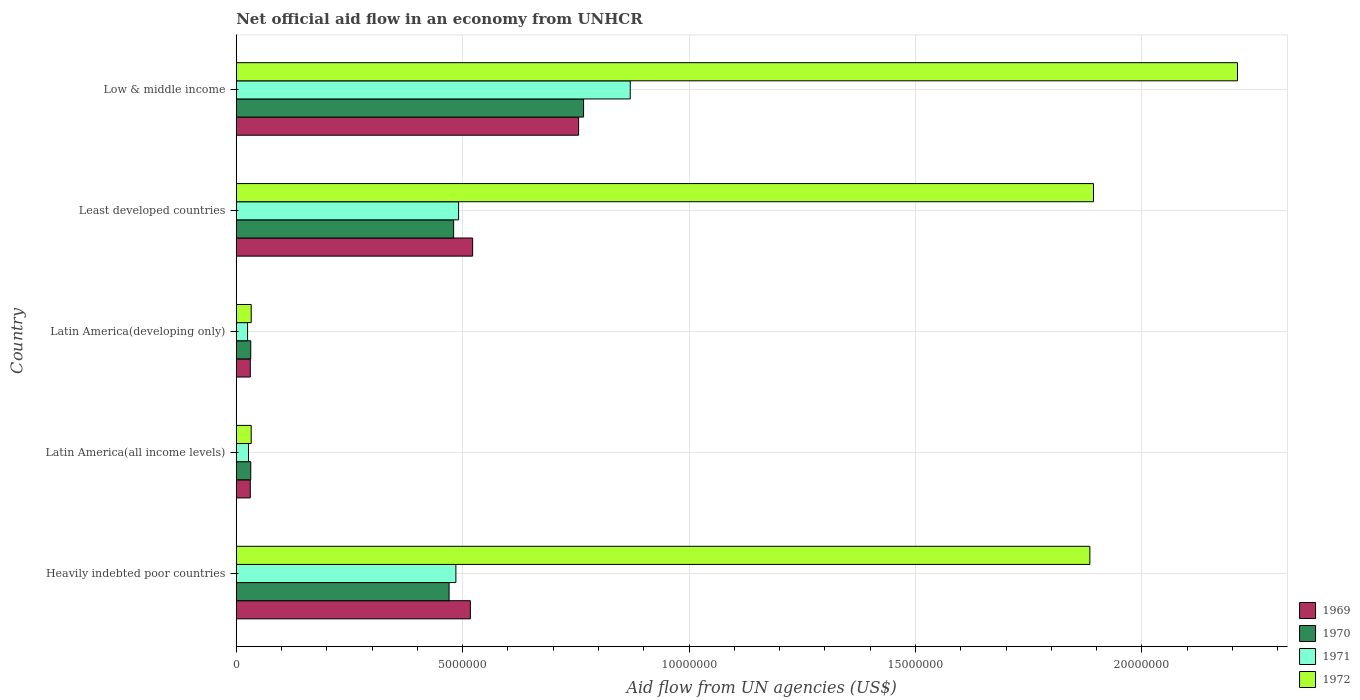Are the number of bars per tick equal to the number of legend labels?
Your answer should be compact. Yes. What is the label of the 2nd group of bars from the top?
Provide a succinct answer. Least developed countries. What is the net official aid flow in 1972 in Heavily indebted poor countries?
Give a very brief answer. 1.88e+07. Across all countries, what is the maximum net official aid flow in 1969?
Your response must be concise. 7.56e+06. Across all countries, what is the minimum net official aid flow in 1972?
Offer a terse response. 3.30e+05. In which country was the net official aid flow in 1971 minimum?
Offer a very short reply. Latin America(developing only). What is the total net official aid flow in 1969 in the graph?
Offer a terse response. 1.86e+07. What is the difference between the net official aid flow in 1971 in Heavily indebted poor countries and that in Latin America(developing only)?
Your answer should be compact. 4.60e+06. What is the average net official aid flow in 1969 per country?
Your response must be concise. 3.71e+06. What is the difference between the net official aid flow in 1971 and net official aid flow in 1970 in Latin America(developing only)?
Your answer should be very brief. -7.00e+04. In how many countries, is the net official aid flow in 1971 greater than 14000000 US$?
Give a very brief answer. 0. What is the ratio of the net official aid flow in 1969 in Latin America(developing only) to that in Least developed countries?
Keep it short and to the point. 0.06. Is the net official aid flow in 1971 in Latin America(all income levels) less than that in Least developed countries?
Make the answer very short. Yes. What is the difference between the highest and the second highest net official aid flow in 1971?
Make the answer very short. 3.79e+06. What is the difference between the highest and the lowest net official aid flow in 1969?
Offer a terse response. 7.25e+06. In how many countries, is the net official aid flow in 1969 greater than the average net official aid flow in 1969 taken over all countries?
Your response must be concise. 3. Is the sum of the net official aid flow in 1971 in Latin America(all income levels) and Latin America(developing only) greater than the maximum net official aid flow in 1969 across all countries?
Provide a short and direct response. No. Is it the case that in every country, the sum of the net official aid flow in 1971 and net official aid flow in 1969 is greater than the sum of net official aid flow in 1972 and net official aid flow in 1970?
Ensure brevity in your answer.  No. What does the 4th bar from the top in Least developed countries represents?
Offer a terse response. 1969. What does the 3rd bar from the bottom in Least developed countries represents?
Give a very brief answer. 1971. How many countries are there in the graph?
Provide a succinct answer. 5. What is the difference between two consecutive major ticks on the X-axis?
Your answer should be very brief. 5.00e+06. How many legend labels are there?
Your response must be concise. 4. What is the title of the graph?
Offer a very short reply. Net official aid flow in an economy from UNHCR. What is the label or title of the X-axis?
Your answer should be compact. Aid flow from UN agencies (US$). What is the Aid flow from UN agencies (US$) of 1969 in Heavily indebted poor countries?
Your answer should be compact. 5.17e+06. What is the Aid flow from UN agencies (US$) in 1970 in Heavily indebted poor countries?
Give a very brief answer. 4.70e+06. What is the Aid flow from UN agencies (US$) of 1971 in Heavily indebted poor countries?
Your response must be concise. 4.85e+06. What is the Aid flow from UN agencies (US$) in 1972 in Heavily indebted poor countries?
Keep it short and to the point. 1.88e+07. What is the Aid flow from UN agencies (US$) in 1970 in Latin America(all income levels)?
Make the answer very short. 3.20e+05. What is the Aid flow from UN agencies (US$) of 1971 in Latin America(all income levels)?
Your response must be concise. 2.70e+05. What is the Aid flow from UN agencies (US$) of 1972 in Latin America(all income levels)?
Your answer should be very brief. 3.30e+05. What is the Aid flow from UN agencies (US$) of 1970 in Latin America(developing only)?
Your answer should be compact. 3.20e+05. What is the Aid flow from UN agencies (US$) in 1969 in Least developed countries?
Offer a terse response. 5.22e+06. What is the Aid flow from UN agencies (US$) in 1970 in Least developed countries?
Offer a terse response. 4.80e+06. What is the Aid flow from UN agencies (US$) in 1971 in Least developed countries?
Your answer should be very brief. 4.91e+06. What is the Aid flow from UN agencies (US$) in 1972 in Least developed countries?
Your answer should be very brief. 1.89e+07. What is the Aid flow from UN agencies (US$) in 1969 in Low & middle income?
Your answer should be very brief. 7.56e+06. What is the Aid flow from UN agencies (US$) of 1970 in Low & middle income?
Offer a very short reply. 7.67e+06. What is the Aid flow from UN agencies (US$) in 1971 in Low & middle income?
Your answer should be very brief. 8.70e+06. What is the Aid flow from UN agencies (US$) of 1972 in Low & middle income?
Offer a terse response. 2.21e+07. Across all countries, what is the maximum Aid flow from UN agencies (US$) of 1969?
Offer a terse response. 7.56e+06. Across all countries, what is the maximum Aid flow from UN agencies (US$) of 1970?
Keep it short and to the point. 7.67e+06. Across all countries, what is the maximum Aid flow from UN agencies (US$) in 1971?
Your answer should be very brief. 8.70e+06. Across all countries, what is the maximum Aid flow from UN agencies (US$) in 1972?
Your answer should be compact. 2.21e+07. Across all countries, what is the minimum Aid flow from UN agencies (US$) of 1972?
Offer a very short reply. 3.30e+05. What is the total Aid flow from UN agencies (US$) in 1969 in the graph?
Provide a succinct answer. 1.86e+07. What is the total Aid flow from UN agencies (US$) of 1970 in the graph?
Your response must be concise. 1.78e+07. What is the total Aid flow from UN agencies (US$) in 1971 in the graph?
Give a very brief answer. 1.90e+07. What is the total Aid flow from UN agencies (US$) of 1972 in the graph?
Your answer should be compact. 6.06e+07. What is the difference between the Aid flow from UN agencies (US$) of 1969 in Heavily indebted poor countries and that in Latin America(all income levels)?
Provide a succinct answer. 4.86e+06. What is the difference between the Aid flow from UN agencies (US$) in 1970 in Heavily indebted poor countries and that in Latin America(all income levels)?
Provide a short and direct response. 4.38e+06. What is the difference between the Aid flow from UN agencies (US$) in 1971 in Heavily indebted poor countries and that in Latin America(all income levels)?
Provide a succinct answer. 4.58e+06. What is the difference between the Aid flow from UN agencies (US$) in 1972 in Heavily indebted poor countries and that in Latin America(all income levels)?
Your answer should be very brief. 1.85e+07. What is the difference between the Aid flow from UN agencies (US$) of 1969 in Heavily indebted poor countries and that in Latin America(developing only)?
Provide a short and direct response. 4.86e+06. What is the difference between the Aid flow from UN agencies (US$) of 1970 in Heavily indebted poor countries and that in Latin America(developing only)?
Keep it short and to the point. 4.38e+06. What is the difference between the Aid flow from UN agencies (US$) in 1971 in Heavily indebted poor countries and that in Latin America(developing only)?
Keep it short and to the point. 4.60e+06. What is the difference between the Aid flow from UN agencies (US$) of 1972 in Heavily indebted poor countries and that in Latin America(developing only)?
Offer a very short reply. 1.85e+07. What is the difference between the Aid flow from UN agencies (US$) of 1969 in Heavily indebted poor countries and that in Least developed countries?
Provide a succinct answer. -5.00e+04. What is the difference between the Aid flow from UN agencies (US$) of 1970 in Heavily indebted poor countries and that in Least developed countries?
Keep it short and to the point. -1.00e+05. What is the difference between the Aid flow from UN agencies (US$) in 1972 in Heavily indebted poor countries and that in Least developed countries?
Your answer should be very brief. -8.00e+04. What is the difference between the Aid flow from UN agencies (US$) of 1969 in Heavily indebted poor countries and that in Low & middle income?
Provide a short and direct response. -2.39e+06. What is the difference between the Aid flow from UN agencies (US$) in 1970 in Heavily indebted poor countries and that in Low & middle income?
Offer a terse response. -2.97e+06. What is the difference between the Aid flow from UN agencies (US$) of 1971 in Heavily indebted poor countries and that in Low & middle income?
Ensure brevity in your answer.  -3.85e+06. What is the difference between the Aid flow from UN agencies (US$) in 1972 in Heavily indebted poor countries and that in Low & middle income?
Offer a terse response. -3.26e+06. What is the difference between the Aid flow from UN agencies (US$) in 1969 in Latin America(all income levels) and that in Least developed countries?
Your answer should be very brief. -4.91e+06. What is the difference between the Aid flow from UN agencies (US$) in 1970 in Latin America(all income levels) and that in Least developed countries?
Your response must be concise. -4.48e+06. What is the difference between the Aid flow from UN agencies (US$) of 1971 in Latin America(all income levels) and that in Least developed countries?
Offer a terse response. -4.64e+06. What is the difference between the Aid flow from UN agencies (US$) of 1972 in Latin America(all income levels) and that in Least developed countries?
Give a very brief answer. -1.86e+07. What is the difference between the Aid flow from UN agencies (US$) in 1969 in Latin America(all income levels) and that in Low & middle income?
Give a very brief answer. -7.25e+06. What is the difference between the Aid flow from UN agencies (US$) in 1970 in Latin America(all income levels) and that in Low & middle income?
Make the answer very short. -7.35e+06. What is the difference between the Aid flow from UN agencies (US$) in 1971 in Latin America(all income levels) and that in Low & middle income?
Offer a very short reply. -8.43e+06. What is the difference between the Aid flow from UN agencies (US$) in 1972 in Latin America(all income levels) and that in Low & middle income?
Keep it short and to the point. -2.18e+07. What is the difference between the Aid flow from UN agencies (US$) in 1969 in Latin America(developing only) and that in Least developed countries?
Offer a very short reply. -4.91e+06. What is the difference between the Aid flow from UN agencies (US$) in 1970 in Latin America(developing only) and that in Least developed countries?
Provide a short and direct response. -4.48e+06. What is the difference between the Aid flow from UN agencies (US$) in 1971 in Latin America(developing only) and that in Least developed countries?
Your answer should be compact. -4.66e+06. What is the difference between the Aid flow from UN agencies (US$) in 1972 in Latin America(developing only) and that in Least developed countries?
Your response must be concise. -1.86e+07. What is the difference between the Aid flow from UN agencies (US$) in 1969 in Latin America(developing only) and that in Low & middle income?
Your answer should be compact. -7.25e+06. What is the difference between the Aid flow from UN agencies (US$) of 1970 in Latin America(developing only) and that in Low & middle income?
Your response must be concise. -7.35e+06. What is the difference between the Aid flow from UN agencies (US$) in 1971 in Latin America(developing only) and that in Low & middle income?
Your answer should be compact. -8.45e+06. What is the difference between the Aid flow from UN agencies (US$) in 1972 in Latin America(developing only) and that in Low & middle income?
Your response must be concise. -2.18e+07. What is the difference between the Aid flow from UN agencies (US$) of 1969 in Least developed countries and that in Low & middle income?
Provide a succinct answer. -2.34e+06. What is the difference between the Aid flow from UN agencies (US$) in 1970 in Least developed countries and that in Low & middle income?
Keep it short and to the point. -2.87e+06. What is the difference between the Aid flow from UN agencies (US$) in 1971 in Least developed countries and that in Low & middle income?
Give a very brief answer. -3.79e+06. What is the difference between the Aid flow from UN agencies (US$) in 1972 in Least developed countries and that in Low & middle income?
Keep it short and to the point. -3.18e+06. What is the difference between the Aid flow from UN agencies (US$) of 1969 in Heavily indebted poor countries and the Aid flow from UN agencies (US$) of 1970 in Latin America(all income levels)?
Your response must be concise. 4.85e+06. What is the difference between the Aid flow from UN agencies (US$) of 1969 in Heavily indebted poor countries and the Aid flow from UN agencies (US$) of 1971 in Latin America(all income levels)?
Your answer should be compact. 4.90e+06. What is the difference between the Aid flow from UN agencies (US$) of 1969 in Heavily indebted poor countries and the Aid flow from UN agencies (US$) of 1972 in Latin America(all income levels)?
Offer a terse response. 4.84e+06. What is the difference between the Aid flow from UN agencies (US$) of 1970 in Heavily indebted poor countries and the Aid flow from UN agencies (US$) of 1971 in Latin America(all income levels)?
Offer a terse response. 4.43e+06. What is the difference between the Aid flow from UN agencies (US$) in 1970 in Heavily indebted poor countries and the Aid flow from UN agencies (US$) in 1972 in Latin America(all income levels)?
Provide a succinct answer. 4.37e+06. What is the difference between the Aid flow from UN agencies (US$) of 1971 in Heavily indebted poor countries and the Aid flow from UN agencies (US$) of 1972 in Latin America(all income levels)?
Give a very brief answer. 4.52e+06. What is the difference between the Aid flow from UN agencies (US$) of 1969 in Heavily indebted poor countries and the Aid flow from UN agencies (US$) of 1970 in Latin America(developing only)?
Your answer should be very brief. 4.85e+06. What is the difference between the Aid flow from UN agencies (US$) of 1969 in Heavily indebted poor countries and the Aid flow from UN agencies (US$) of 1971 in Latin America(developing only)?
Ensure brevity in your answer.  4.92e+06. What is the difference between the Aid flow from UN agencies (US$) of 1969 in Heavily indebted poor countries and the Aid flow from UN agencies (US$) of 1972 in Latin America(developing only)?
Offer a terse response. 4.84e+06. What is the difference between the Aid flow from UN agencies (US$) of 1970 in Heavily indebted poor countries and the Aid flow from UN agencies (US$) of 1971 in Latin America(developing only)?
Your answer should be very brief. 4.45e+06. What is the difference between the Aid flow from UN agencies (US$) in 1970 in Heavily indebted poor countries and the Aid flow from UN agencies (US$) in 1972 in Latin America(developing only)?
Provide a short and direct response. 4.37e+06. What is the difference between the Aid flow from UN agencies (US$) of 1971 in Heavily indebted poor countries and the Aid flow from UN agencies (US$) of 1972 in Latin America(developing only)?
Offer a terse response. 4.52e+06. What is the difference between the Aid flow from UN agencies (US$) of 1969 in Heavily indebted poor countries and the Aid flow from UN agencies (US$) of 1970 in Least developed countries?
Provide a succinct answer. 3.70e+05. What is the difference between the Aid flow from UN agencies (US$) of 1969 in Heavily indebted poor countries and the Aid flow from UN agencies (US$) of 1972 in Least developed countries?
Offer a very short reply. -1.38e+07. What is the difference between the Aid flow from UN agencies (US$) in 1970 in Heavily indebted poor countries and the Aid flow from UN agencies (US$) in 1972 in Least developed countries?
Your answer should be very brief. -1.42e+07. What is the difference between the Aid flow from UN agencies (US$) of 1971 in Heavily indebted poor countries and the Aid flow from UN agencies (US$) of 1972 in Least developed countries?
Ensure brevity in your answer.  -1.41e+07. What is the difference between the Aid flow from UN agencies (US$) in 1969 in Heavily indebted poor countries and the Aid flow from UN agencies (US$) in 1970 in Low & middle income?
Ensure brevity in your answer.  -2.50e+06. What is the difference between the Aid flow from UN agencies (US$) in 1969 in Heavily indebted poor countries and the Aid flow from UN agencies (US$) in 1971 in Low & middle income?
Your answer should be very brief. -3.53e+06. What is the difference between the Aid flow from UN agencies (US$) in 1969 in Heavily indebted poor countries and the Aid flow from UN agencies (US$) in 1972 in Low & middle income?
Keep it short and to the point. -1.69e+07. What is the difference between the Aid flow from UN agencies (US$) of 1970 in Heavily indebted poor countries and the Aid flow from UN agencies (US$) of 1972 in Low & middle income?
Provide a succinct answer. -1.74e+07. What is the difference between the Aid flow from UN agencies (US$) of 1971 in Heavily indebted poor countries and the Aid flow from UN agencies (US$) of 1972 in Low & middle income?
Give a very brief answer. -1.73e+07. What is the difference between the Aid flow from UN agencies (US$) of 1969 in Latin America(all income levels) and the Aid flow from UN agencies (US$) of 1972 in Latin America(developing only)?
Offer a very short reply. -2.00e+04. What is the difference between the Aid flow from UN agencies (US$) of 1971 in Latin America(all income levels) and the Aid flow from UN agencies (US$) of 1972 in Latin America(developing only)?
Your answer should be very brief. -6.00e+04. What is the difference between the Aid flow from UN agencies (US$) in 1969 in Latin America(all income levels) and the Aid flow from UN agencies (US$) in 1970 in Least developed countries?
Keep it short and to the point. -4.49e+06. What is the difference between the Aid flow from UN agencies (US$) of 1969 in Latin America(all income levels) and the Aid flow from UN agencies (US$) of 1971 in Least developed countries?
Provide a succinct answer. -4.60e+06. What is the difference between the Aid flow from UN agencies (US$) of 1969 in Latin America(all income levels) and the Aid flow from UN agencies (US$) of 1972 in Least developed countries?
Your answer should be compact. -1.86e+07. What is the difference between the Aid flow from UN agencies (US$) in 1970 in Latin America(all income levels) and the Aid flow from UN agencies (US$) in 1971 in Least developed countries?
Make the answer very short. -4.59e+06. What is the difference between the Aid flow from UN agencies (US$) in 1970 in Latin America(all income levels) and the Aid flow from UN agencies (US$) in 1972 in Least developed countries?
Keep it short and to the point. -1.86e+07. What is the difference between the Aid flow from UN agencies (US$) in 1971 in Latin America(all income levels) and the Aid flow from UN agencies (US$) in 1972 in Least developed countries?
Provide a short and direct response. -1.87e+07. What is the difference between the Aid flow from UN agencies (US$) of 1969 in Latin America(all income levels) and the Aid flow from UN agencies (US$) of 1970 in Low & middle income?
Offer a terse response. -7.36e+06. What is the difference between the Aid flow from UN agencies (US$) in 1969 in Latin America(all income levels) and the Aid flow from UN agencies (US$) in 1971 in Low & middle income?
Your answer should be compact. -8.39e+06. What is the difference between the Aid flow from UN agencies (US$) in 1969 in Latin America(all income levels) and the Aid flow from UN agencies (US$) in 1972 in Low & middle income?
Your response must be concise. -2.18e+07. What is the difference between the Aid flow from UN agencies (US$) of 1970 in Latin America(all income levels) and the Aid flow from UN agencies (US$) of 1971 in Low & middle income?
Provide a succinct answer. -8.38e+06. What is the difference between the Aid flow from UN agencies (US$) of 1970 in Latin America(all income levels) and the Aid flow from UN agencies (US$) of 1972 in Low & middle income?
Keep it short and to the point. -2.18e+07. What is the difference between the Aid flow from UN agencies (US$) of 1971 in Latin America(all income levels) and the Aid flow from UN agencies (US$) of 1972 in Low & middle income?
Ensure brevity in your answer.  -2.18e+07. What is the difference between the Aid flow from UN agencies (US$) in 1969 in Latin America(developing only) and the Aid flow from UN agencies (US$) in 1970 in Least developed countries?
Offer a very short reply. -4.49e+06. What is the difference between the Aid flow from UN agencies (US$) of 1969 in Latin America(developing only) and the Aid flow from UN agencies (US$) of 1971 in Least developed countries?
Provide a succinct answer. -4.60e+06. What is the difference between the Aid flow from UN agencies (US$) of 1969 in Latin America(developing only) and the Aid flow from UN agencies (US$) of 1972 in Least developed countries?
Provide a short and direct response. -1.86e+07. What is the difference between the Aid flow from UN agencies (US$) in 1970 in Latin America(developing only) and the Aid flow from UN agencies (US$) in 1971 in Least developed countries?
Provide a short and direct response. -4.59e+06. What is the difference between the Aid flow from UN agencies (US$) in 1970 in Latin America(developing only) and the Aid flow from UN agencies (US$) in 1972 in Least developed countries?
Offer a very short reply. -1.86e+07. What is the difference between the Aid flow from UN agencies (US$) of 1971 in Latin America(developing only) and the Aid flow from UN agencies (US$) of 1972 in Least developed countries?
Your answer should be compact. -1.87e+07. What is the difference between the Aid flow from UN agencies (US$) in 1969 in Latin America(developing only) and the Aid flow from UN agencies (US$) in 1970 in Low & middle income?
Keep it short and to the point. -7.36e+06. What is the difference between the Aid flow from UN agencies (US$) in 1969 in Latin America(developing only) and the Aid flow from UN agencies (US$) in 1971 in Low & middle income?
Make the answer very short. -8.39e+06. What is the difference between the Aid flow from UN agencies (US$) in 1969 in Latin America(developing only) and the Aid flow from UN agencies (US$) in 1972 in Low & middle income?
Keep it short and to the point. -2.18e+07. What is the difference between the Aid flow from UN agencies (US$) of 1970 in Latin America(developing only) and the Aid flow from UN agencies (US$) of 1971 in Low & middle income?
Your answer should be compact. -8.38e+06. What is the difference between the Aid flow from UN agencies (US$) in 1970 in Latin America(developing only) and the Aid flow from UN agencies (US$) in 1972 in Low & middle income?
Your answer should be compact. -2.18e+07. What is the difference between the Aid flow from UN agencies (US$) of 1971 in Latin America(developing only) and the Aid flow from UN agencies (US$) of 1972 in Low & middle income?
Keep it short and to the point. -2.19e+07. What is the difference between the Aid flow from UN agencies (US$) of 1969 in Least developed countries and the Aid flow from UN agencies (US$) of 1970 in Low & middle income?
Provide a succinct answer. -2.45e+06. What is the difference between the Aid flow from UN agencies (US$) of 1969 in Least developed countries and the Aid flow from UN agencies (US$) of 1971 in Low & middle income?
Keep it short and to the point. -3.48e+06. What is the difference between the Aid flow from UN agencies (US$) of 1969 in Least developed countries and the Aid flow from UN agencies (US$) of 1972 in Low & middle income?
Provide a short and direct response. -1.69e+07. What is the difference between the Aid flow from UN agencies (US$) in 1970 in Least developed countries and the Aid flow from UN agencies (US$) in 1971 in Low & middle income?
Offer a terse response. -3.90e+06. What is the difference between the Aid flow from UN agencies (US$) of 1970 in Least developed countries and the Aid flow from UN agencies (US$) of 1972 in Low & middle income?
Ensure brevity in your answer.  -1.73e+07. What is the difference between the Aid flow from UN agencies (US$) in 1971 in Least developed countries and the Aid flow from UN agencies (US$) in 1972 in Low & middle income?
Your answer should be compact. -1.72e+07. What is the average Aid flow from UN agencies (US$) in 1969 per country?
Keep it short and to the point. 3.71e+06. What is the average Aid flow from UN agencies (US$) of 1970 per country?
Your answer should be compact. 3.56e+06. What is the average Aid flow from UN agencies (US$) in 1971 per country?
Keep it short and to the point. 3.80e+06. What is the average Aid flow from UN agencies (US$) in 1972 per country?
Your answer should be compact. 1.21e+07. What is the difference between the Aid flow from UN agencies (US$) of 1969 and Aid flow from UN agencies (US$) of 1972 in Heavily indebted poor countries?
Your answer should be very brief. -1.37e+07. What is the difference between the Aid flow from UN agencies (US$) of 1970 and Aid flow from UN agencies (US$) of 1972 in Heavily indebted poor countries?
Provide a succinct answer. -1.42e+07. What is the difference between the Aid flow from UN agencies (US$) of 1971 and Aid flow from UN agencies (US$) of 1972 in Heavily indebted poor countries?
Offer a terse response. -1.40e+07. What is the difference between the Aid flow from UN agencies (US$) of 1970 and Aid flow from UN agencies (US$) of 1971 in Latin America(all income levels)?
Provide a short and direct response. 5.00e+04. What is the difference between the Aid flow from UN agencies (US$) of 1970 and Aid flow from UN agencies (US$) of 1972 in Latin America(all income levels)?
Your answer should be very brief. -10000. What is the difference between the Aid flow from UN agencies (US$) of 1971 and Aid flow from UN agencies (US$) of 1972 in Latin America(all income levels)?
Ensure brevity in your answer.  -6.00e+04. What is the difference between the Aid flow from UN agencies (US$) in 1970 and Aid flow from UN agencies (US$) in 1972 in Latin America(developing only)?
Offer a very short reply. -10000. What is the difference between the Aid flow from UN agencies (US$) of 1969 and Aid flow from UN agencies (US$) of 1970 in Least developed countries?
Provide a succinct answer. 4.20e+05. What is the difference between the Aid flow from UN agencies (US$) in 1969 and Aid flow from UN agencies (US$) in 1972 in Least developed countries?
Ensure brevity in your answer.  -1.37e+07. What is the difference between the Aid flow from UN agencies (US$) in 1970 and Aid flow from UN agencies (US$) in 1972 in Least developed countries?
Your answer should be compact. -1.41e+07. What is the difference between the Aid flow from UN agencies (US$) of 1971 and Aid flow from UN agencies (US$) of 1972 in Least developed countries?
Offer a terse response. -1.40e+07. What is the difference between the Aid flow from UN agencies (US$) of 1969 and Aid flow from UN agencies (US$) of 1971 in Low & middle income?
Provide a succinct answer. -1.14e+06. What is the difference between the Aid flow from UN agencies (US$) of 1969 and Aid flow from UN agencies (US$) of 1972 in Low & middle income?
Make the answer very short. -1.46e+07. What is the difference between the Aid flow from UN agencies (US$) in 1970 and Aid flow from UN agencies (US$) in 1971 in Low & middle income?
Give a very brief answer. -1.03e+06. What is the difference between the Aid flow from UN agencies (US$) of 1970 and Aid flow from UN agencies (US$) of 1972 in Low & middle income?
Your answer should be very brief. -1.44e+07. What is the difference between the Aid flow from UN agencies (US$) of 1971 and Aid flow from UN agencies (US$) of 1972 in Low & middle income?
Your answer should be compact. -1.34e+07. What is the ratio of the Aid flow from UN agencies (US$) of 1969 in Heavily indebted poor countries to that in Latin America(all income levels)?
Keep it short and to the point. 16.68. What is the ratio of the Aid flow from UN agencies (US$) of 1970 in Heavily indebted poor countries to that in Latin America(all income levels)?
Your response must be concise. 14.69. What is the ratio of the Aid flow from UN agencies (US$) in 1971 in Heavily indebted poor countries to that in Latin America(all income levels)?
Your answer should be compact. 17.96. What is the ratio of the Aid flow from UN agencies (US$) in 1972 in Heavily indebted poor countries to that in Latin America(all income levels)?
Give a very brief answer. 57.12. What is the ratio of the Aid flow from UN agencies (US$) in 1969 in Heavily indebted poor countries to that in Latin America(developing only)?
Offer a very short reply. 16.68. What is the ratio of the Aid flow from UN agencies (US$) of 1970 in Heavily indebted poor countries to that in Latin America(developing only)?
Your response must be concise. 14.69. What is the ratio of the Aid flow from UN agencies (US$) of 1971 in Heavily indebted poor countries to that in Latin America(developing only)?
Offer a very short reply. 19.4. What is the ratio of the Aid flow from UN agencies (US$) in 1972 in Heavily indebted poor countries to that in Latin America(developing only)?
Ensure brevity in your answer.  57.12. What is the ratio of the Aid flow from UN agencies (US$) in 1970 in Heavily indebted poor countries to that in Least developed countries?
Offer a terse response. 0.98. What is the ratio of the Aid flow from UN agencies (US$) in 1971 in Heavily indebted poor countries to that in Least developed countries?
Keep it short and to the point. 0.99. What is the ratio of the Aid flow from UN agencies (US$) of 1969 in Heavily indebted poor countries to that in Low & middle income?
Make the answer very short. 0.68. What is the ratio of the Aid flow from UN agencies (US$) in 1970 in Heavily indebted poor countries to that in Low & middle income?
Make the answer very short. 0.61. What is the ratio of the Aid flow from UN agencies (US$) of 1971 in Heavily indebted poor countries to that in Low & middle income?
Provide a short and direct response. 0.56. What is the ratio of the Aid flow from UN agencies (US$) of 1972 in Heavily indebted poor countries to that in Low & middle income?
Your answer should be compact. 0.85. What is the ratio of the Aid flow from UN agencies (US$) of 1969 in Latin America(all income levels) to that in Latin America(developing only)?
Make the answer very short. 1. What is the ratio of the Aid flow from UN agencies (US$) of 1971 in Latin America(all income levels) to that in Latin America(developing only)?
Ensure brevity in your answer.  1.08. What is the ratio of the Aid flow from UN agencies (US$) of 1969 in Latin America(all income levels) to that in Least developed countries?
Provide a short and direct response. 0.06. What is the ratio of the Aid flow from UN agencies (US$) of 1970 in Latin America(all income levels) to that in Least developed countries?
Provide a short and direct response. 0.07. What is the ratio of the Aid flow from UN agencies (US$) in 1971 in Latin America(all income levels) to that in Least developed countries?
Your answer should be very brief. 0.06. What is the ratio of the Aid flow from UN agencies (US$) in 1972 in Latin America(all income levels) to that in Least developed countries?
Provide a short and direct response. 0.02. What is the ratio of the Aid flow from UN agencies (US$) of 1969 in Latin America(all income levels) to that in Low & middle income?
Ensure brevity in your answer.  0.04. What is the ratio of the Aid flow from UN agencies (US$) in 1970 in Latin America(all income levels) to that in Low & middle income?
Give a very brief answer. 0.04. What is the ratio of the Aid flow from UN agencies (US$) in 1971 in Latin America(all income levels) to that in Low & middle income?
Offer a very short reply. 0.03. What is the ratio of the Aid flow from UN agencies (US$) in 1972 in Latin America(all income levels) to that in Low & middle income?
Your answer should be compact. 0.01. What is the ratio of the Aid flow from UN agencies (US$) in 1969 in Latin America(developing only) to that in Least developed countries?
Your response must be concise. 0.06. What is the ratio of the Aid flow from UN agencies (US$) in 1970 in Latin America(developing only) to that in Least developed countries?
Offer a very short reply. 0.07. What is the ratio of the Aid flow from UN agencies (US$) in 1971 in Latin America(developing only) to that in Least developed countries?
Ensure brevity in your answer.  0.05. What is the ratio of the Aid flow from UN agencies (US$) of 1972 in Latin America(developing only) to that in Least developed countries?
Give a very brief answer. 0.02. What is the ratio of the Aid flow from UN agencies (US$) of 1969 in Latin America(developing only) to that in Low & middle income?
Provide a short and direct response. 0.04. What is the ratio of the Aid flow from UN agencies (US$) of 1970 in Latin America(developing only) to that in Low & middle income?
Your response must be concise. 0.04. What is the ratio of the Aid flow from UN agencies (US$) in 1971 in Latin America(developing only) to that in Low & middle income?
Give a very brief answer. 0.03. What is the ratio of the Aid flow from UN agencies (US$) of 1972 in Latin America(developing only) to that in Low & middle income?
Keep it short and to the point. 0.01. What is the ratio of the Aid flow from UN agencies (US$) of 1969 in Least developed countries to that in Low & middle income?
Your answer should be very brief. 0.69. What is the ratio of the Aid flow from UN agencies (US$) of 1970 in Least developed countries to that in Low & middle income?
Offer a very short reply. 0.63. What is the ratio of the Aid flow from UN agencies (US$) of 1971 in Least developed countries to that in Low & middle income?
Make the answer very short. 0.56. What is the ratio of the Aid flow from UN agencies (US$) in 1972 in Least developed countries to that in Low & middle income?
Your answer should be compact. 0.86. What is the difference between the highest and the second highest Aid flow from UN agencies (US$) in 1969?
Offer a terse response. 2.34e+06. What is the difference between the highest and the second highest Aid flow from UN agencies (US$) of 1970?
Your answer should be very brief. 2.87e+06. What is the difference between the highest and the second highest Aid flow from UN agencies (US$) in 1971?
Give a very brief answer. 3.79e+06. What is the difference between the highest and the second highest Aid flow from UN agencies (US$) of 1972?
Your response must be concise. 3.18e+06. What is the difference between the highest and the lowest Aid flow from UN agencies (US$) of 1969?
Offer a very short reply. 7.25e+06. What is the difference between the highest and the lowest Aid flow from UN agencies (US$) in 1970?
Provide a short and direct response. 7.35e+06. What is the difference between the highest and the lowest Aid flow from UN agencies (US$) in 1971?
Provide a succinct answer. 8.45e+06. What is the difference between the highest and the lowest Aid flow from UN agencies (US$) in 1972?
Ensure brevity in your answer.  2.18e+07. 